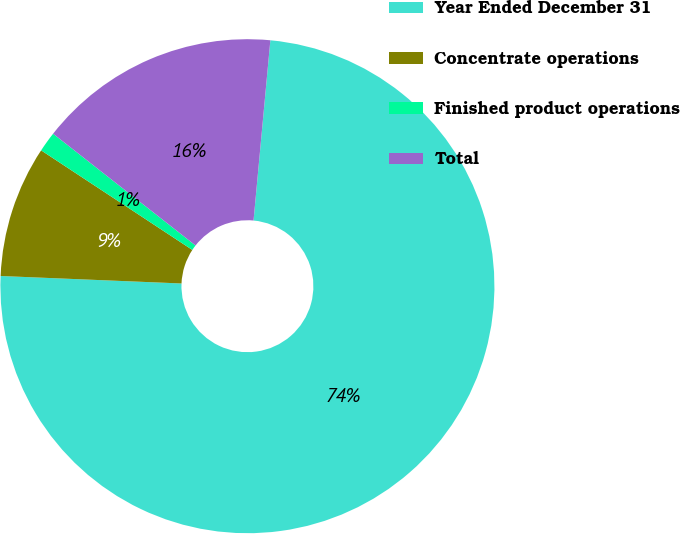Convert chart. <chart><loc_0><loc_0><loc_500><loc_500><pie_chart><fcel>Year Ended December 31<fcel>Concentrate operations<fcel>Finished product operations<fcel>Total<nl><fcel>74.17%<fcel>8.61%<fcel>1.32%<fcel>15.89%<nl></chart> 